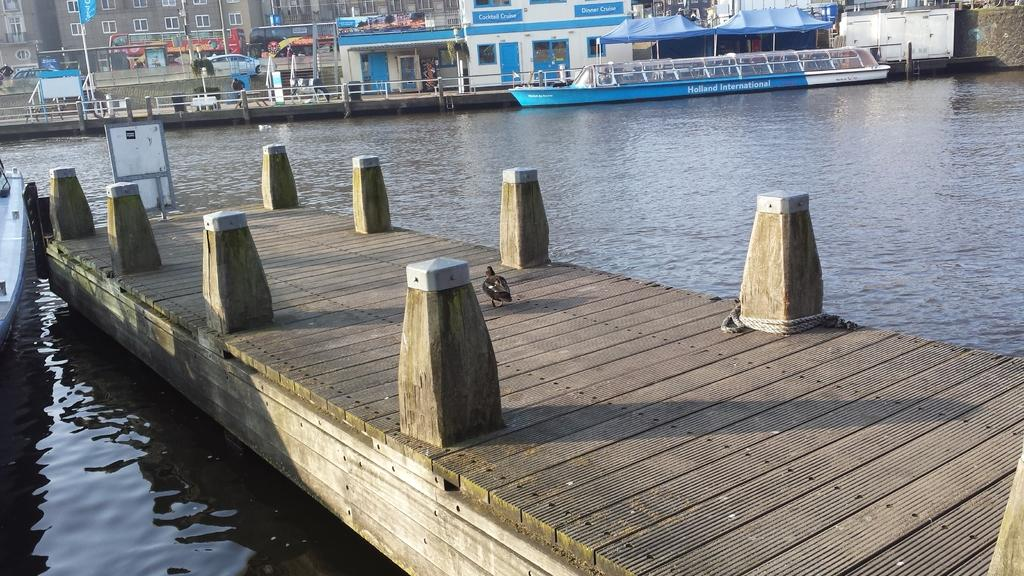What type of structure is visible in the image? There is a deck with small poles in the image. What animal can be seen on the deck? A bird is present on the deck. What can be seen in the water in the image? There is a boat on the water. What architectural features are visible in the background of the image? Railings, buildings, and poles are present in the background of the image. What type of temporary shelter is visible in the background of the image? Tents are visible in the background of the image. What type of baseball equipment can be seen in the image? There is no baseball equipment present in the image. What type of learning materials can be seen in the image? There are no learning materials present in the image. 